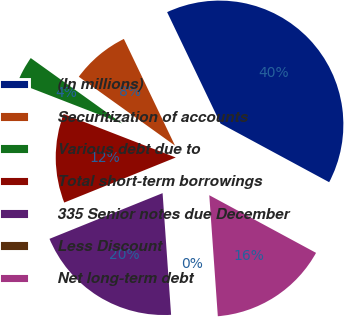Convert chart to OTSL. <chart><loc_0><loc_0><loc_500><loc_500><pie_chart><fcel>(In millions)<fcel>Securitization of accounts<fcel>Various debt due to<fcel>Total short-term borrowings<fcel>335 Senior notes due December<fcel>Less Discount<fcel>Net long-term debt<nl><fcel>39.99%<fcel>8.0%<fcel>4.0%<fcel>12.0%<fcel>20.0%<fcel>0.01%<fcel>16.0%<nl></chart> 